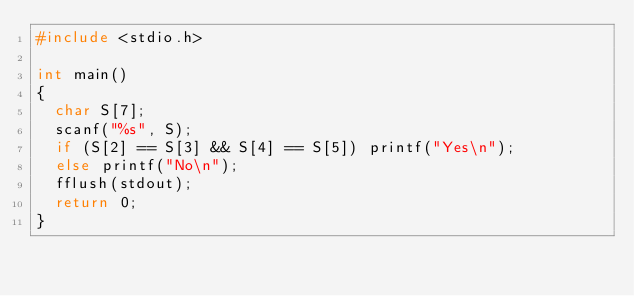Convert code to text. <code><loc_0><loc_0><loc_500><loc_500><_C_>#include <stdio.h>

int main()
{
	char S[7];
	scanf("%s", S);
	if (S[2] == S[3] && S[4] == S[5]) printf("Yes\n");
	else printf("No\n");
	fflush(stdout);
	return 0;
}</code> 